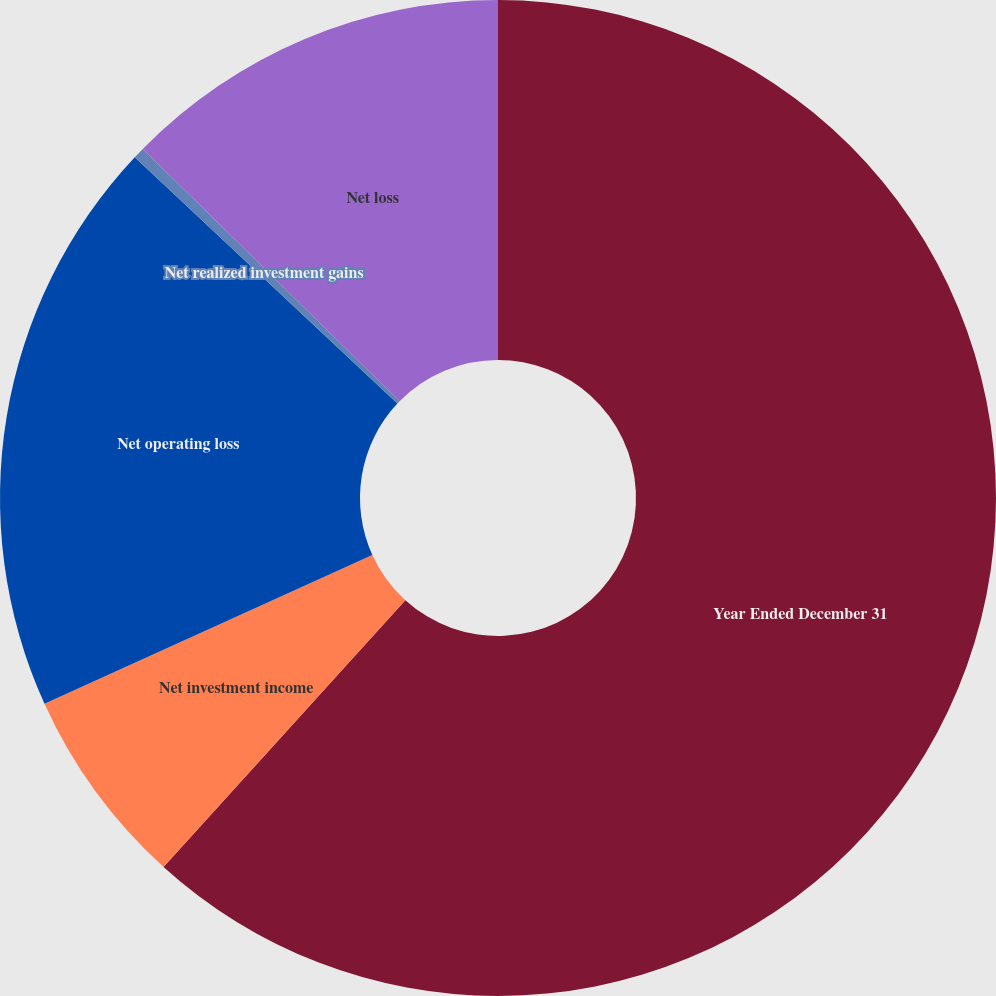Convert chart to OTSL. <chart><loc_0><loc_0><loc_500><loc_500><pie_chart><fcel>Year Ended December 31<fcel>Net investment income<fcel>Net operating loss<fcel>Net realized investment gains<fcel>Net loss<nl><fcel>61.72%<fcel>6.5%<fcel>18.77%<fcel>0.37%<fcel>12.64%<nl></chart> 